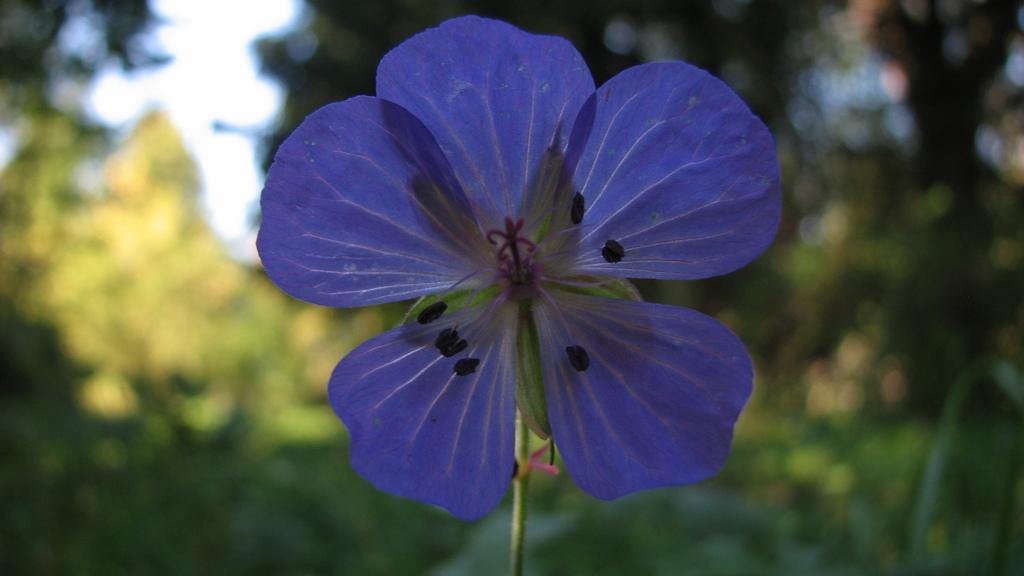What is the main subject of the image? There is a flower in the image. What can be seen in the background of the image? There are trees behind the flower in the image. Can you touch the straw in the image? There is no straw present in the image. 